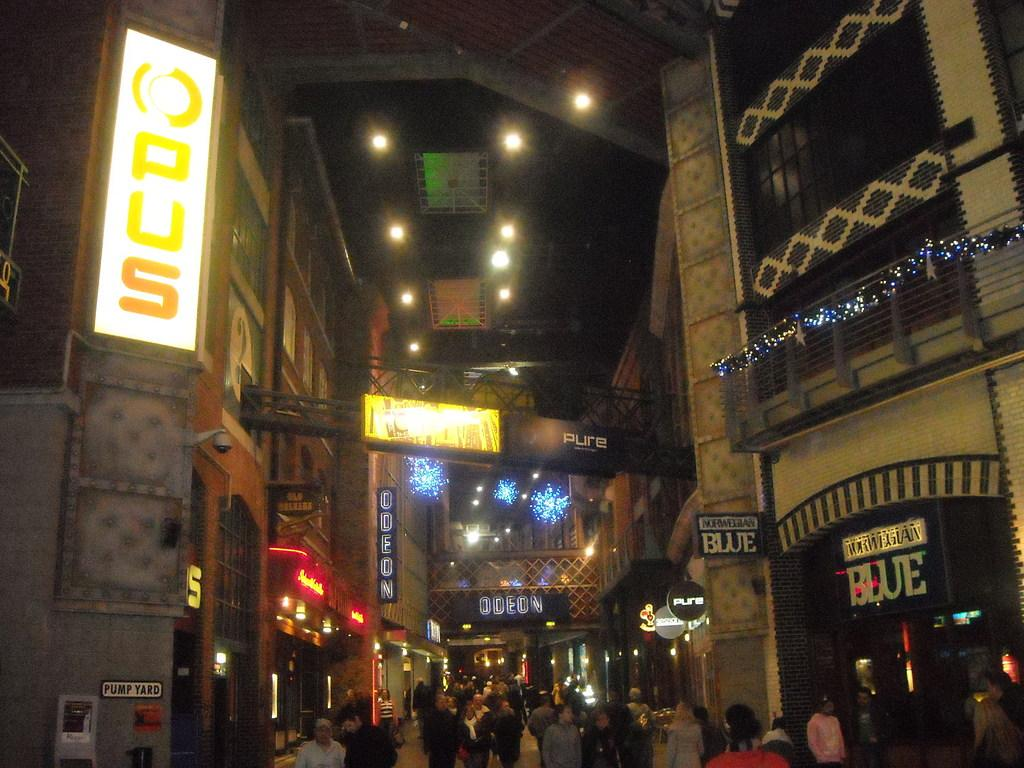What type of structures can be seen in the image? There are buildings in the image. Are there any specific features connecting the buildings? Yes, there are connecting bridges in the image. What type of lighting is present in the image? Street lights are visible in the image. What type of signage is present in the image? Information boards and name boards are present in the image. What are the people in the image doing? People are walking on the road in the image. What type of security feature is visible in the image? Grills are visible in the image. Where is the shelf located in the image? There is no shelf present in the image. What type of store can be seen in the image? There is no store present in the image. 